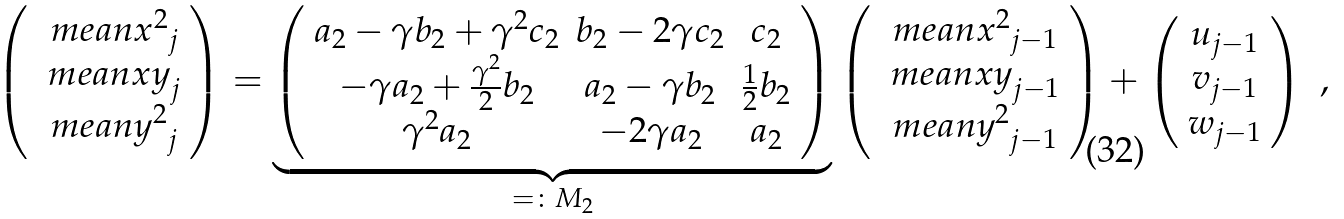<formula> <loc_0><loc_0><loc_500><loc_500>\left ( \begin{array} { c } \ m e a n { x ^ { 2 } } _ { j } \\ \ m e a n { x y } _ { j } \\ \ m e a n { y ^ { 2 } } _ { j } \end{array} \right ) = \underbrace { \left ( \begin{array} { c c c } a _ { 2 } - \gamma b _ { 2 } + \gamma ^ { 2 } c _ { 2 } & b _ { 2 } - 2 \gamma c _ { 2 } & c _ { 2 } \\ - \gamma a _ { 2 } + \frac { \gamma ^ { 2 } } { 2 } b _ { 2 } & a _ { 2 } - \gamma b _ { 2 } & \frac { 1 } { 2 } b _ { 2 } \\ \gamma ^ { 2 } a _ { 2 } & - 2 \gamma a _ { 2 } & a _ { 2 } \end{array} \right ) } _ { = \colon M _ { 2 } } \left ( \begin{array} { c } \ m e a n { x ^ { 2 } } _ { j - 1 } \\ \ m e a n { x y } _ { j - 1 } \\ \ m e a n { y ^ { 2 } } _ { j - 1 } \end{array} \right ) + \left ( \begin{array} { c } u _ { j - 1 } \\ v _ { j - 1 } \\ w _ { j - 1 } \end{array} \right ) \ ,</formula> 